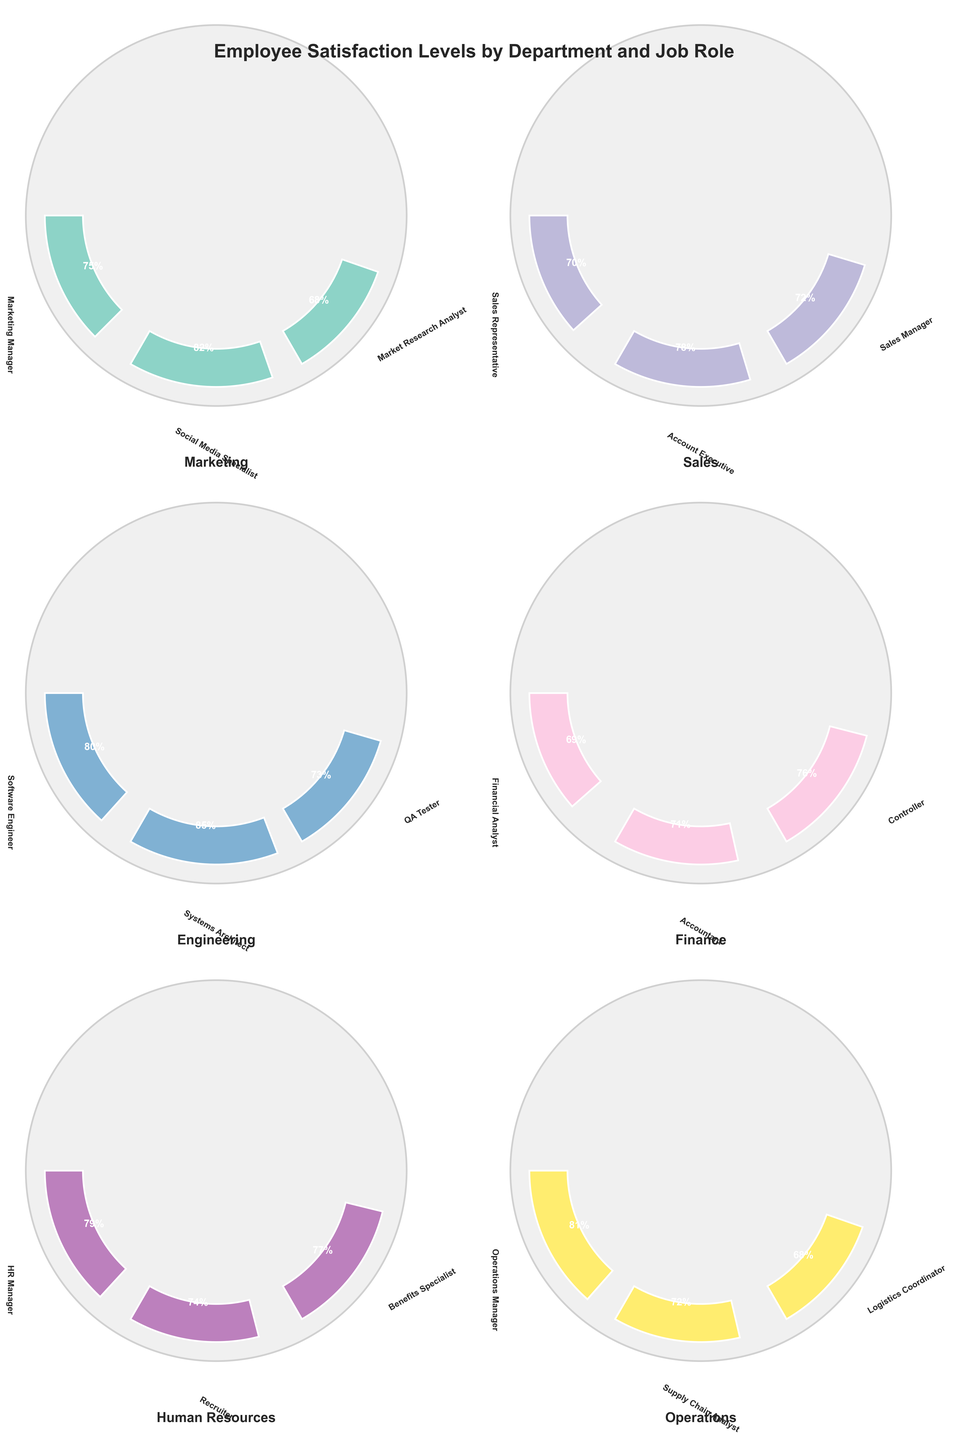What is the title of the figure? The title is usually found at the top of the figure. In this case, it reads "Employee Satisfaction Levels by Department and Job Role".
Answer: Employee Satisfaction Levels by Department and Job Role How many departments are visualized in the figure? Count the number of unique departments listed in the figure. Each department has its own gauge chart. There are six departments in total: Marketing, Sales, Engineering, Finance, Human Resources, and Operations.
Answer: Six Which job role within the Marketing department has the highest satisfaction level? Look at the gauge chart for the Marketing department and identify the job role with the highest percentage displayed. The Social Media Specialist has the highest satisfaction level of 82%.
Answer: Social Media Specialist Compare the satisfaction levels of the Software Engineer and QA Tester in the Engineering department. Which is higher and by how much? Locate the gauge arcs for the Software Engineer and QA Tester within the Engineering department. The Software Engineer has a satisfaction level of 80%, while the QA Tester has a satisfaction level of 73%. Subtracting these values gives a difference of 7%.
Answer: Software Engineer, 7% What is the average satisfaction level for the job roles in the Sales department? Sum the satisfaction levels of the job roles in the Sales department: (70 + 78 + 72) = 220. Then, divide by the number of job roles (3) to get the average: 220 / 3 = approximately 73.33%.
Answer: 73.33% Which department has the employee with the lowest satisfaction level, and what is that level? Look at all the gauge charts and identify the job role with the lowest satisfaction level. The Logistics Coordinator in the Operations department has the lowest satisfaction level of 68%.
Answer: Operations, 68% What is the range of satisfaction levels within the Finance department? Identify the maximum and minimum satisfaction levels within the Finance department. The highest is the Controller at 76%, and the lowest is the Financial Analyst at 69%. Subtract the minimum from the maximum: 76% - 69% = 7%.
Answer: 7% Is there any department with all job roles having satisfaction levels greater than 75%? Check each department's job roles to see if all satisfaction levels are above 75%. Only the Engineering department meets this criterion, with all satisfaction levels being 80% or greater.
Answer: Yes, Engineering Which job role has the satisfaction level closest to 70%, and in which department is it? Look for job roles with satisfaction levels near 70%. The Sales Representative in the Sales department has a satisfaction level of precisely 70%.
Answer: Sales Representative, Sales What is the overall satisfaction level range across all departments, and which job roles represent these extremes? Find the highest and lowest satisfaction levels across all departments. The Systems Architect in Engineering has the highest at 85%, and the Logistics Coordinator in Operations has the lowest at 68%. The overall range is 85% - 68% = 17%.
Answer: 17%, Systems Architect (Engineering) and Logistics Coordinator (Operations) 